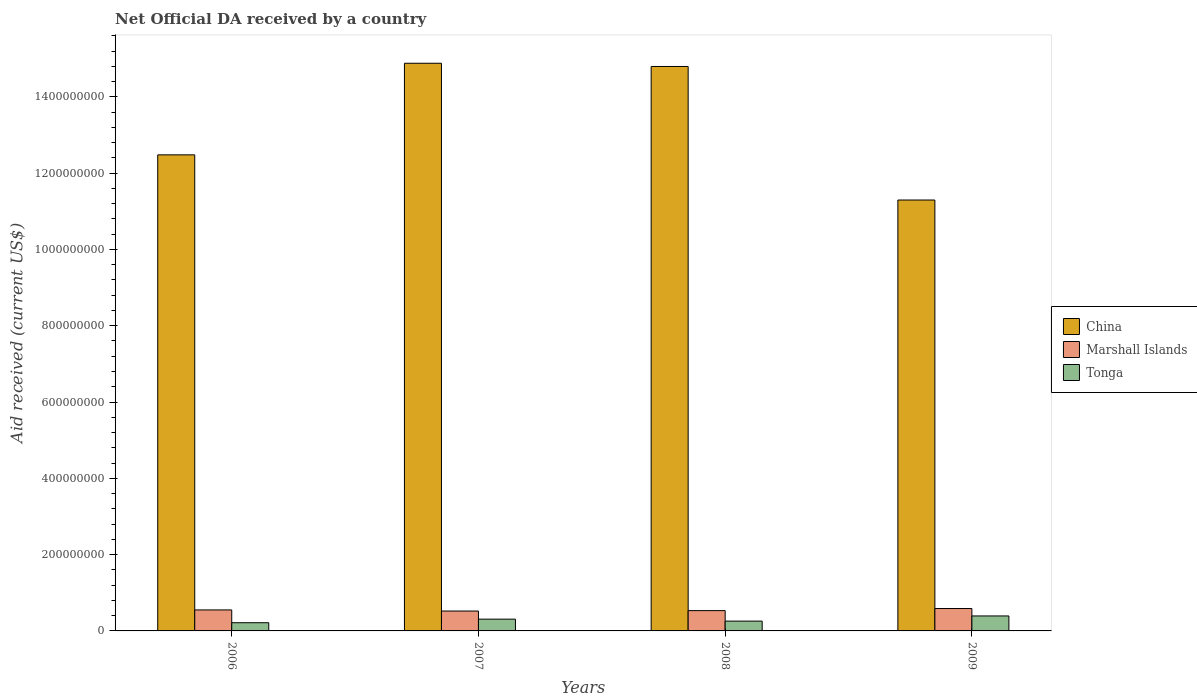How many different coloured bars are there?
Ensure brevity in your answer.  3. How many groups of bars are there?
Your answer should be compact. 4. Are the number of bars on each tick of the X-axis equal?
Offer a very short reply. Yes. How many bars are there on the 4th tick from the left?
Provide a short and direct response. 3. How many bars are there on the 2nd tick from the right?
Provide a short and direct response. 3. In how many cases, is the number of bars for a given year not equal to the number of legend labels?
Provide a short and direct response. 0. What is the net official development assistance aid received in Marshall Islands in 2006?
Make the answer very short. 5.50e+07. Across all years, what is the maximum net official development assistance aid received in China?
Your answer should be compact. 1.49e+09. Across all years, what is the minimum net official development assistance aid received in Marshall Islands?
Give a very brief answer. 5.21e+07. In which year was the net official development assistance aid received in Marshall Islands maximum?
Offer a very short reply. 2009. What is the total net official development assistance aid received in Marshall Islands in the graph?
Your answer should be very brief. 2.19e+08. What is the difference between the net official development assistance aid received in Marshall Islands in 2008 and that in 2009?
Offer a very short reply. -5.48e+06. What is the difference between the net official development assistance aid received in Marshall Islands in 2007 and the net official development assistance aid received in Tonga in 2009?
Ensure brevity in your answer.  1.29e+07. What is the average net official development assistance aid received in Tonga per year?
Provide a short and direct response. 2.93e+07. In the year 2006, what is the difference between the net official development assistance aid received in China and net official development assistance aid received in Marshall Islands?
Provide a succinct answer. 1.19e+09. In how many years, is the net official development assistance aid received in Marshall Islands greater than 720000000 US$?
Provide a short and direct response. 0. What is the ratio of the net official development assistance aid received in Marshall Islands in 2006 to that in 2007?
Provide a short and direct response. 1.06. Is the net official development assistance aid received in Tonga in 2007 less than that in 2009?
Your answer should be compact. Yes. What is the difference between the highest and the second highest net official development assistance aid received in Tonga?
Give a very brief answer. 8.38e+06. What is the difference between the highest and the lowest net official development assistance aid received in Marshall Islands?
Keep it short and to the point. 6.58e+06. In how many years, is the net official development assistance aid received in China greater than the average net official development assistance aid received in China taken over all years?
Keep it short and to the point. 2. Is the sum of the net official development assistance aid received in China in 2006 and 2008 greater than the maximum net official development assistance aid received in Marshall Islands across all years?
Keep it short and to the point. Yes. What does the 3rd bar from the left in 2006 represents?
Your answer should be compact. Tonga. What does the 1st bar from the right in 2009 represents?
Make the answer very short. Tonga. Is it the case that in every year, the sum of the net official development assistance aid received in Marshall Islands and net official development assistance aid received in China is greater than the net official development assistance aid received in Tonga?
Keep it short and to the point. Yes. How many bars are there?
Your answer should be compact. 12. Are the values on the major ticks of Y-axis written in scientific E-notation?
Your answer should be very brief. No. Where does the legend appear in the graph?
Provide a succinct answer. Center right. How are the legend labels stacked?
Give a very brief answer. Vertical. What is the title of the graph?
Keep it short and to the point. Net Official DA received by a country. Does "Djibouti" appear as one of the legend labels in the graph?
Make the answer very short. No. What is the label or title of the X-axis?
Your response must be concise. Years. What is the label or title of the Y-axis?
Your answer should be compact. Aid received (current US$). What is the Aid received (current US$) of China in 2006?
Your answer should be compact. 1.25e+09. What is the Aid received (current US$) in Marshall Islands in 2006?
Your answer should be very brief. 5.50e+07. What is the Aid received (current US$) in Tonga in 2006?
Your answer should be compact. 2.15e+07. What is the Aid received (current US$) of China in 2007?
Give a very brief answer. 1.49e+09. What is the Aid received (current US$) in Marshall Islands in 2007?
Provide a succinct answer. 5.21e+07. What is the Aid received (current US$) of Tonga in 2007?
Your response must be concise. 3.09e+07. What is the Aid received (current US$) of China in 2008?
Your response must be concise. 1.48e+09. What is the Aid received (current US$) in Marshall Islands in 2008?
Keep it short and to the point. 5.32e+07. What is the Aid received (current US$) in Tonga in 2008?
Provide a short and direct response. 2.57e+07. What is the Aid received (current US$) of China in 2009?
Offer a very short reply. 1.13e+09. What is the Aid received (current US$) of Marshall Islands in 2009?
Provide a succinct answer. 5.87e+07. What is the Aid received (current US$) in Tonga in 2009?
Offer a terse response. 3.92e+07. Across all years, what is the maximum Aid received (current US$) of China?
Provide a short and direct response. 1.49e+09. Across all years, what is the maximum Aid received (current US$) in Marshall Islands?
Make the answer very short. 5.87e+07. Across all years, what is the maximum Aid received (current US$) of Tonga?
Your answer should be very brief. 3.92e+07. Across all years, what is the minimum Aid received (current US$) in China?
Provide a succinct answer. 1.13e+09. Across all years, what is the minimum Aid received (current US$) in Marshall Islands?
Your response must be concise. 5.21e+07. Across all years, what is the minimum Aid received (current US$) in Tonga?
Your response must be concise. 2.15e+07. What is the total Aid received (current US$) of China in the graph?
Your answer should be compact. 5.34e+09. What is the total Aid received (current US$) of Marshall Islands in the graph?
Keep it short and to the point. 2.19e+08. What is the total Aid received (current US$) of Tonga in the graph?
Keep it short and to the point. 1.17e+08. What is the difference between the Aid received (current US$) in China in 2006 and that in 2007?
Offer a very short reply. -2.40e+08. What is the difference between the Aid received (current US$) in Marshall Islands in 2006 and that in 2007?
Your response must be concise. 2.92e+06. What is the difference between the Aid received (current US$) in Tonga in 2006 and that in 2007?
Your answer should be compact. -9.37e+06. What is the difference between the Aid received (current US$) in China in 2006 and that in 2008?
Ensure brevity in your answer.  -2.32e+08. What is the difference between the Aid received (current US$) in Marshall Islands in 2006 and that in 2008?
Your response must be concise. 1.82e+06. What is the difference between the Aid received (current US$) in Tonga in 2006 and that in 2008?
Your answer should be compact. -4.22e+06. What is the difference between the Aid received (current US$) of China in 2006 and that in 2009?
Provide a short and direct response. 1.18e+08. What is the difference between the Aid received (current US$) in Marshall Islands in 2006 and that in 2009?
Your answer should be very brief. -3.66e+06. What is the difference between the Aid received (current US$) of Tonga in 2006 and that in 2009?
Provide a short and direct response. -1.78e+07. What is the difference between the Aid received (current US$) in China in 2007 and that in 2008?
Ensure brevity in your answer.  8.43e+06. What is the difference between the Aid received (current US$) of Marshall Islands in 2007 and that in 2008?
Offer a very short reply. -1.10e+06. What is the difference between the Aid received (current US$) in Tonga in 2007 and that in 2008?
Give a very brief answer. 5.15e+06. What is the difference between the Aid received (current US$) in China in 2007 and that in 2009?
Your answer should be very brief. 3.58e+08. What is the difference between the Aid received (current US$) of Marshall Islands in 2007 and that in 2009?
Ensure brevity in your answer.  -6.58e+06. What is the difference between the Aid received (current US$) of Tonga in 2007 and that in 2009?
Provide a short and direct response. -8.38e+06. What is the difference between the Aid received (current US$) of China in 2008 and that in 2009?
Provide a short and direct response. 3.50e+08. What is the difference between the Aid received (current US$) in Marshall Islands in 2008 and that in 2009?
Your response must be concise. -5.48e+06. What is the difference between the Aid received (current US$) of Tonga in 2008 and that in 2009?
Ensure brevity in your answer.  -1.35e+07. What is the difference between the Aid received (current US$) in China in 2006 and the Aid received (current US$) in Marshall Islands in 2007?
Keep it short and to the point. 1.20e+09. What is the difference between the Aid received (current US$) of China in 2006 and the Aid received (current US$) of Tonga in 2007?
Keep it short and to the point. 1.22e+09. What is the difference between the Aid received (current US$) of Marshall Islands in 2006 and the Aid received (current US$) of Tonga in 2007?
Ensure brevity in your answer.  2.42e+07. What is the difference between the Aid received (current US$) in China in 2006 and the Aid received (current US$) in Marshall Islands in 2008?
Offer a very short reply. 1.19e+09. What is the difference between the Aid received (current US$) of China in 2006 and the Aid received (current US$) of Tonga in 2008?
Make the answer very short. 1.22e+09. What is the difference between the Aid received (current US$) of Marshall Islands in 2006 and the Aid received (current US$) of Tonga in 2008?
Make the answer very short. 2.93e+07. What is the difference between the Aid received (current US$) of China in 2006 and the Aid received (current US$) of Marshall Islands in 2009?
Offer a terse response. 1.19e+09. What is the difference between the Aid received (current US$) of China in 2006 and the Aid received (current US$) of Tonga in 2009?
Offer a terse response. 1.21e+09. What is the difference between the Aid received (current US$) of Marshall Islands in 2006 and the Aid received (current US$) of Tonga in 2009?
Ensure brevity in your answer.  1.58e+07. What is the difference between the Aid received (current US$) of China in 2007 and the Aid received (current US$) of Marshall Islands in 2008?
Keep it short and to the point. 1.43e+09. What is the difference between the Aid received (current US$) in China in 2007 and the Aid received (current US$) in Tonga in 2008?
Offer a terse response. 1.46e+09. What is the difference between the Aid received (current US$) of Marshall Islands in 2007 and the Aid received (current US$) of Tonga in 2008?
Ensure brevity in your answer.  2.64e+07. What is the difference between the Aid received (current US$) of China in 2007 and the Aid received (current US$) of Marshall Islands in 2009?
Give a very brief answer. 1.43e+09. What is the difference between the Aid received (current US$) in China in 2007 and the Aid received (current US$) in Tonga in 2009?
Keep it short and to the point. 1.45e+09. What is the difference between the Aid received (current US$) in Marshall Islands in 2007 and the Aid received (current US$) in Tonga in 2009?
Keep it short and to the point. 1.29e+07. What is the difference between the Aid received (current US$) of China in 2008 and the Aid received (current US$) of Marshall Islands in 2009?
Your response must be concise. 1.42e+09. What is the difference between the Aid received (current US$) in China in 2008 and the Aid received (current US$) in Tonga in 2009?
Provide a succinct answer. 1.44e+09. What is the difference between the Aid received (current US$) of Marshall Islands in 2008 and the Aid received (current US$) of Tonga in 2009?
Your answer should be compact. 1.40e+07. What is the average Aid received (current US$) of China per year?
Your response must be concise. 1.34e+09. What is the average Aid received (current US$) of Marshall Islands per year?
Your answer should be very brief. 5.48e+07. What is the average Aid received (current US$) of Tonga per year?
Offer a terse response. 2.93e+07. In the year 2006, what is the difference between the Aid received (current US$) in China and Aid received (current US$) in Marshall Islands?
Provide a short and direct response. 1.19e+09. In the year 2006, what is the difference between the Aid received (current US$) of China and Aid received (current US$) of Tonga?
Provide a succinct answer. 1.23e+09. In the year 2006, what is the difference between the Aid received (current US$) in Marshall Islands and Aid received (current US$) in Tonga?
Your answer should be compact. 3.36e+07. In the year 2007, what is the difference between the Aid received (current US$) of China and Aid received (current US$) of Marshall Islands?
Provide a short and direct response. 1.44e+09. In the year 2007, what is the difference between the Aid received (current US$) of China and Aid received (current US$) of Tonga?
Your response must be concise. 1.46e+09. In the year 2007, what is the difference between the Aid received (current US$) in Marshall Islands and Aid received (current US$) in Tonga?
Provide a short and direct response. 2.13e+07. In the year 2008, what is the difference between the Aid received (current US$) in China and Aid received (current US$) in Marshall Islands?
Your answer should be compact. 1.43e+09. In the year 2008, what is the difference between the Aid received (current US$) of China and Aid received (current US$) of Tonga?
Your response must be concise. 1.45e+09. In the year 2008, what is the difference between the Aid received (current US$) of Marshall Islands and Aid received (current US$) of Tonga?
Your answer should be compact. 2.75e+07. In the year 2009, what is the difference between the Aid received (current US$) of China and Aid received (current US$) of Marshall Islands?
Provide a short and direct response. 1.07e+09. In the year 2009, what is the difference between the Aid received (current US$) in China and Aid received (current US$) in Tonga?
Keep it short and to the point. 1.09e+09. In the year 2009, what is the difference between the Aid received (current US$) of Marshall Islands and Aid received (current US$) of Tonga?
Offer a very short reply. 1.95e+07. What is the ratio of the Aid received (current US$) in China in 2006 to that in 2007?
Provide a short and direct response. 0.84. What is the ratio of the Aid received (current US$) in Marshall Islands in 2006 to that in 2007?
Your answer should be very brief. 1.06. What is the ratio of the Aid received (current US$) of Tonga in 2006 to that in 2007?
Your answer should be very brief. 0.7. What is the ratio of the Aid received (current US$) in China in 2006 to that in 2008?
Provide a short and direct response. 0.84. What is the ratio of the Aid received (current US$) of Marshall Islands in 2006 to that in 2008?
Your answer should be compact. 1.03. What is the ratio of the Aid received (current US$) in Tonga in 2006 to that in 2008?
Keep it short and to the point. 0.84. What is the ratio of the Aid received (current US$) in China in 2006 to that in 2009?
Provide a succinct answer. 1.1. What is the ratio of the Aid received (current US$) in Marshall Islands in 2006 to that in 2009?
Your answer should be compact. 0.94. What is the ratio of the Aid received (current US$) in Tonga in 2006 to that in 2009?
Keep it short and to the point. 0.55. What is the ratio of the Aid received (current US$) in China in 2007 to that in 2008?
Offer a very short reply. 1.01. What is the ratio of the Aid received (current US$) in Marshall Islands in 2007 to that in 2008?
Provide a short and direct response. 0.98. What is the ratio of the Aid received (current US$) of Tonga in 2007 to that in 2008?
Provide a succinct answer. 1.2. What is the ratio of the Aid received (current US$) in China in 2007 to that in 2009?
Ensure brevity in your answer.  1.32. What is the ratio of the Aid received (current US$) of Marshall Islands in 2007 to that in 2009?
Give a very brief answer. 0.89. What is the ratio of the Aid received (current US$) of Tonga in 2007 to that in 2009?
Make the answer very short. 0.79. What is the ratio of the Aid received (current US$) of China in 2008 to that in 2009?
Provide a short and direct response. 1.31. What is the ratio of the Aid received (current US$) of Marshall Islands in 2008 to that in 2009?
Provide a succinct answer. 0.91. What is the ratio of the Aid received (current US$) of Tonga in 2008 to that in 2009?
Offer a terse response. 0.66. What is the difference between the highest and the second highest Aid received (current US$) in China?
Make the answer very short. 8.43e+06. What is the difference between the highest and the second highest Aid received (current US$) of Marshall Islands?
Give a very brief answer. 3.66e+06. What is the difference between the highest and the second highest Aid received (current US$) in Tonga?
Your answer should be compact. 8.38e+06. What is the difference between the highest and the lowest Aid received (current US$) in China?
Provide a short and direct response. 3.58e+08. What is the difference between the highest and the lowest Aid received (current US$) in Marshall Islands?
Make the answer very short. 6.58e+06. What is the difference between the highest and the lowest Aid received (current US$) of Tonga?
Give a very brief answer. 1.78e+07. 